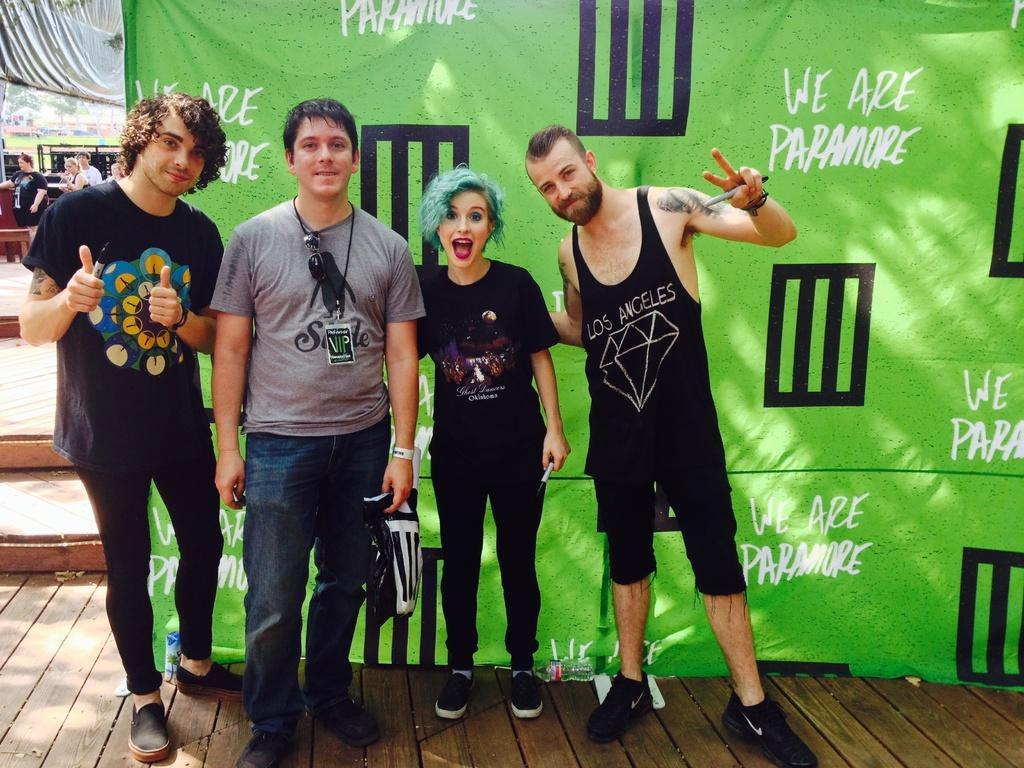What is the main subject of the image? The main subject of the image is a group of persons standing in the center. Where are the persons standing? The group of persons is standing on the floor. What can be seen in the background of the image? There is a certain (likely a building or structure) and another group of persons in the background of the image. Are there any architectural features visible in the background? Yes, there are stairs visible in the background of the image. What type of polish is being applied to the ornament in the image? There is no ornament or polish present in the image. What is inside the box that is visible in the image? There is no box present in the image. 